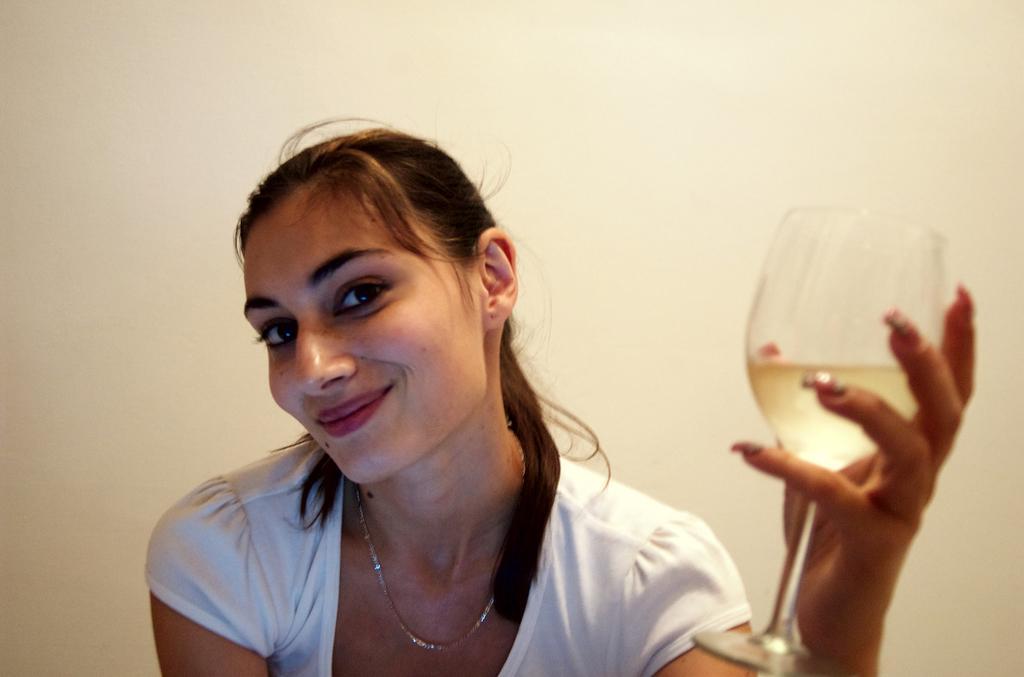In one or two sentences, can you explain what this image depicts? In the picture there is a woman sitting and smiling and holding a wine glass and in the background there is a wall which is off cream color 